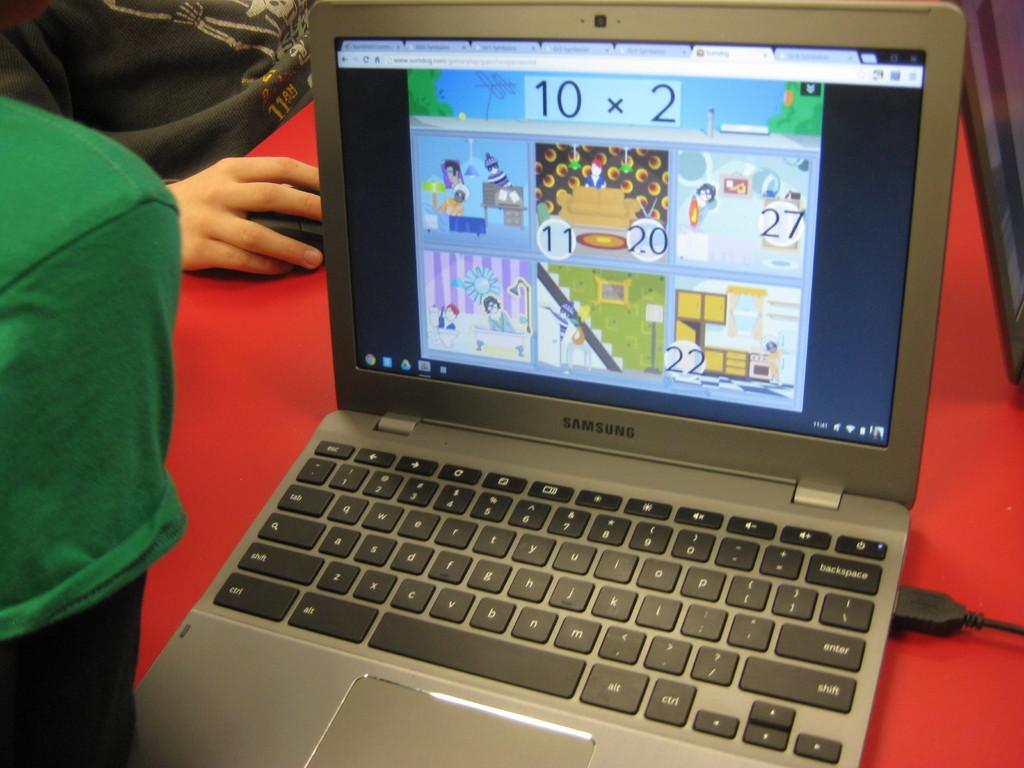Provide a one-sentence caption for the provided image. a laptop displaying what appears to be child math games. 